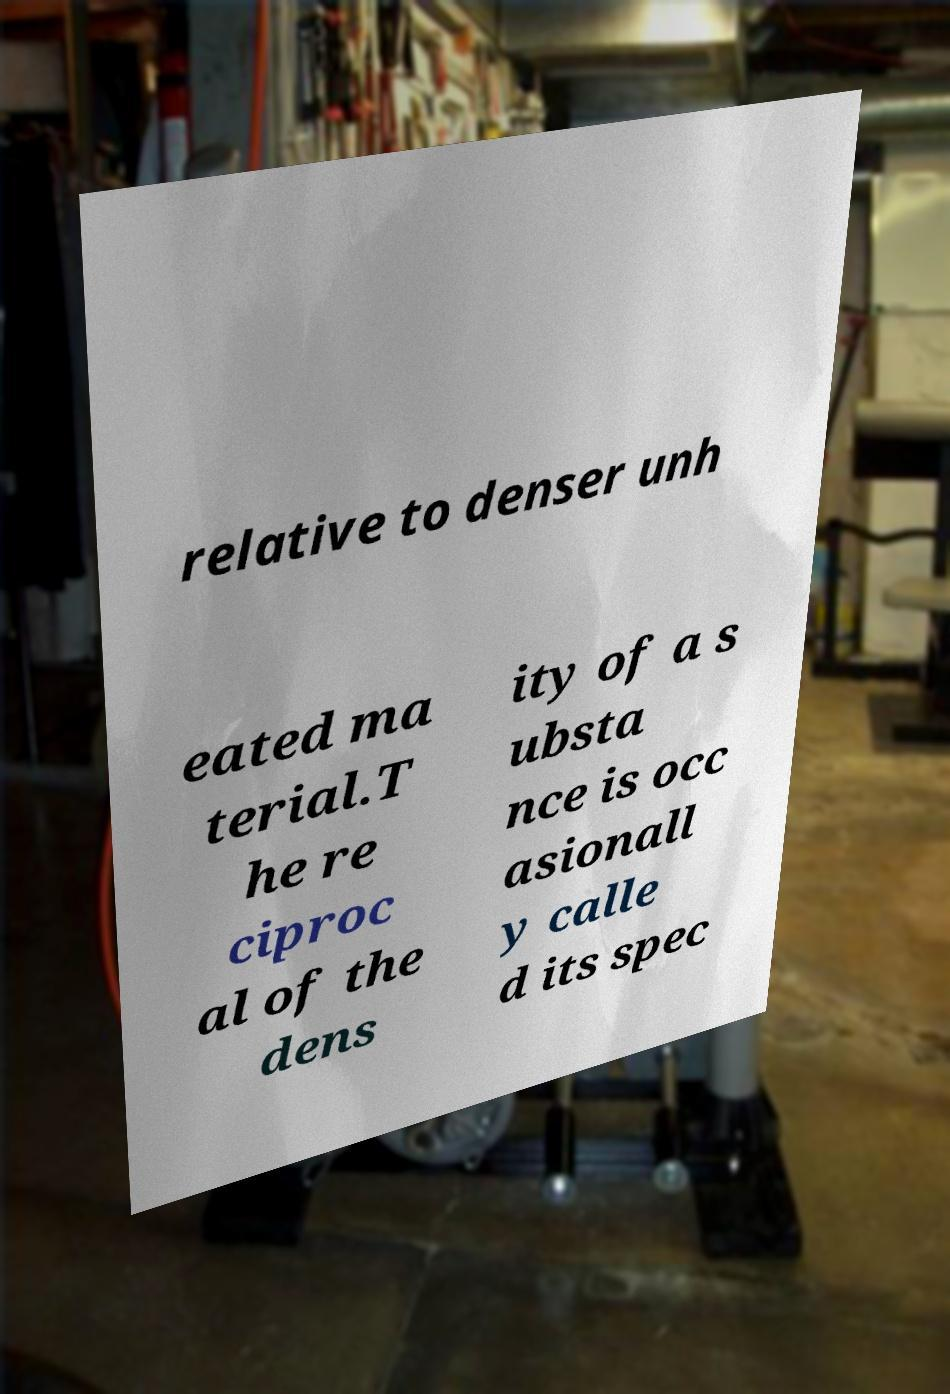Can you accurately transcribe the text from the provided image for me? relative to denser unh eated ma terial.T he re ciproc al of the dens ity of a s ubsta nce is occ asionall y calle d its spec 